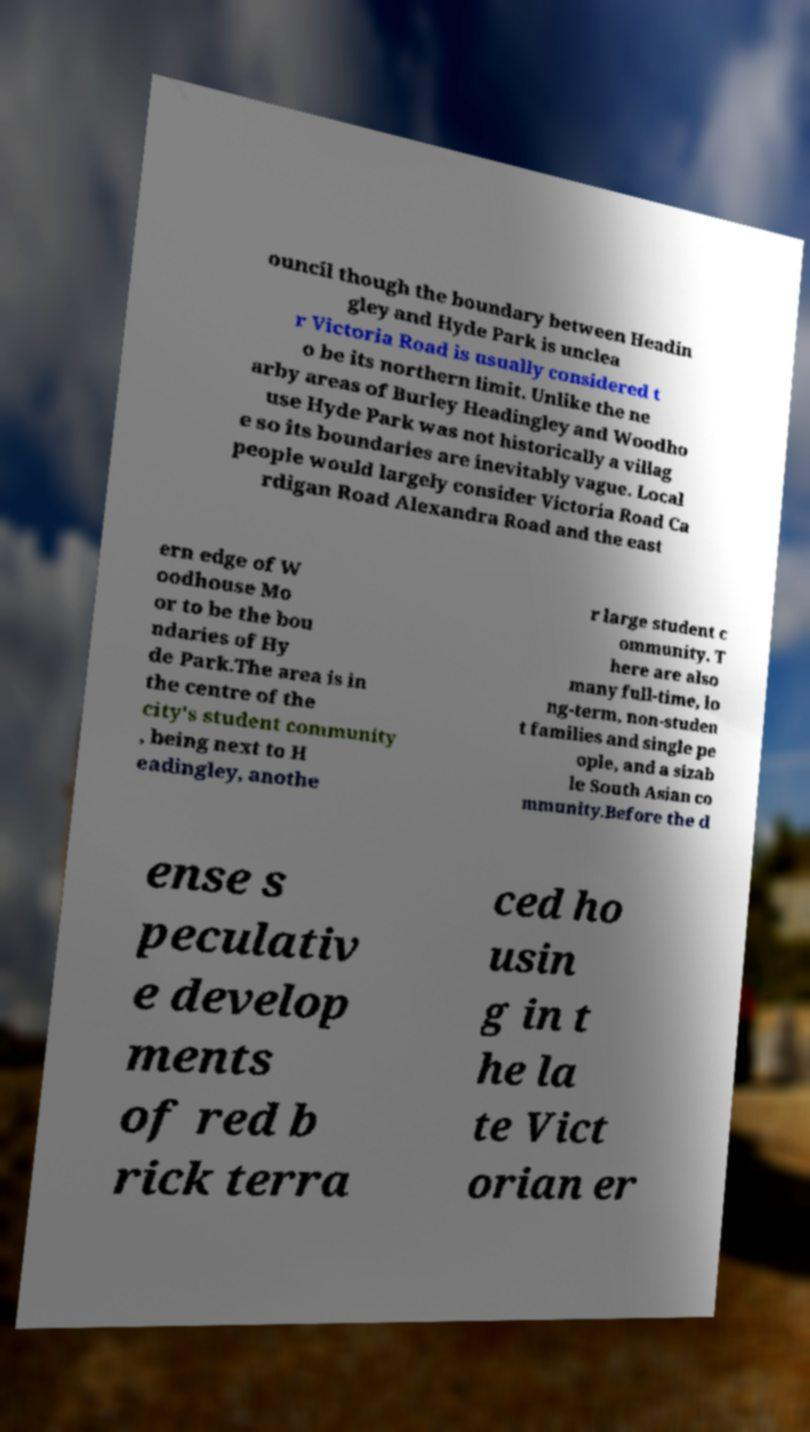Please identify and transcribe the text found in this image. ouncil though the boundary between Headin gley and Hyde Park is unclea r Victoria Road is usually considered t o be its northern limit. Unlike the ne arby areas of Burley Headingley and Woodho use Hyde Park was not historically a villag e so its boundaries are inevitably vague. Local people would largely consider Victoria Road Ca rdigan Road Alexandra Road and the east ern edge of W oodhouse Mo or to be the bou ndaries of Hy de Park.The area is in the centre of the city's student community , being next to H eadingley, anothe r large student c ommunity. T here are also many full-time, lo ng-term, non-studen t families and single pe ople, and a sizab le South Asian co mmunity.Before the d ense s peculativ e develop ments of red b rick terra ced ho usin g in t he la te Vict orian er 